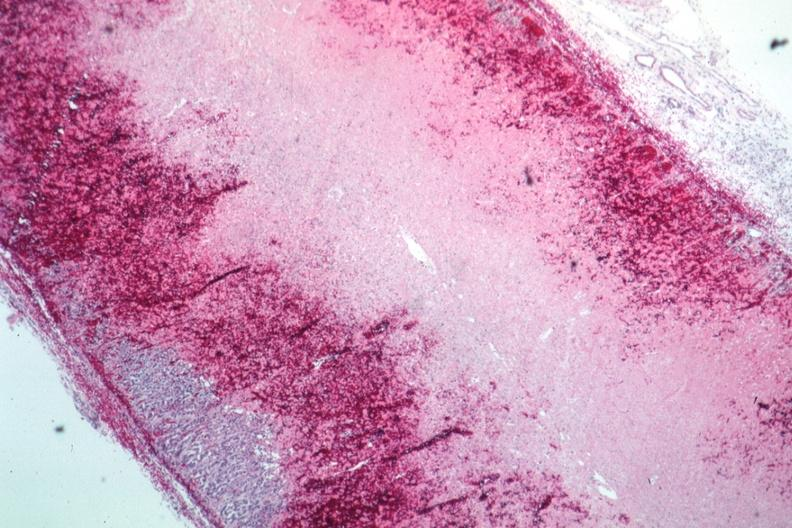does all the fat necrosis show infarction and hemorrhage well shown?
Answer the question using a single word or phrase. No 